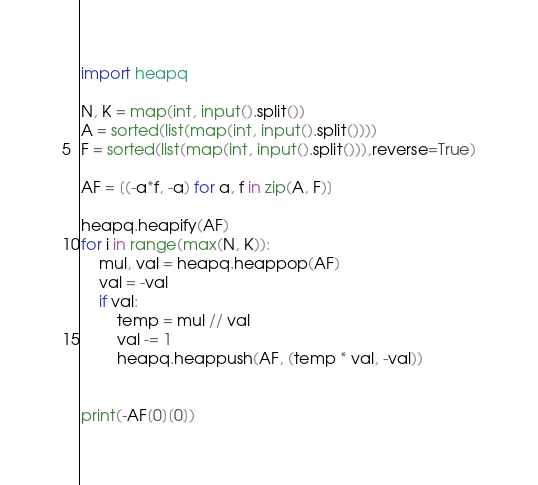Convert code to text. <code><loc_0><loc_0><loc_500><loc_500><_Python_>import heapq

N, K = map(int, input().split())
A = sorted(list(map(int, input().split())))
F = sorted(list(map(int, input().split())),reverse=True)

AF = [(-a*f, -a) for a, f in zip(A, F)]

heapq.heapify(AF)
for i in range(max(N, K)):
    mul, val = heapq.heappop(AF)
    val = -val
    if val:
        temp = mul // val
        val -= 1
        heapq.heappush(AF, (temp * val, -val))


print(-AF[0][0])</code> 